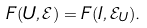<formula> <loc_0><loc_0><loc_500><loc_500>F ( U , \mathcal { E } ) = F ( I , \mathcal { E } _ { U } ) .</formula> 